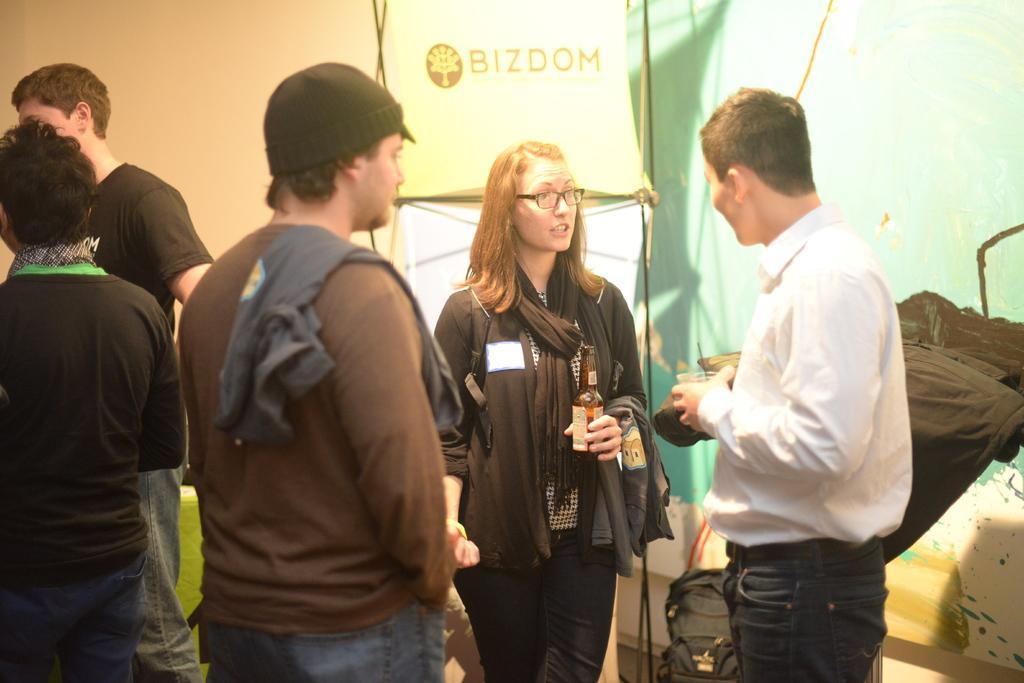Can you describe this image briefly? In the center of the image we can see a few people are standing. Among them, we can see two people are holding some objects. And the middle person is wearing a hat. In the background there is a wall, banner, backpack, black color object and a few other objects. 